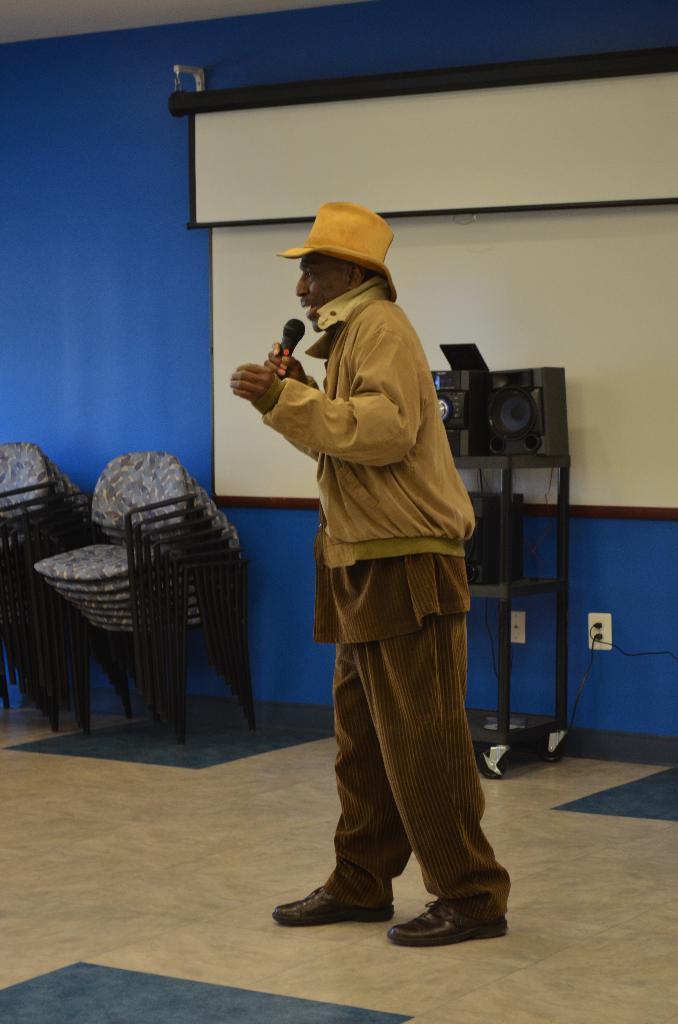Could you give a brief overview of what you see in this image? In this image I can see a person is holding a mic and wearing brown color dress. Back Side I can see few chairs and speaker. I can see a white color screen. The wall is blue color. 